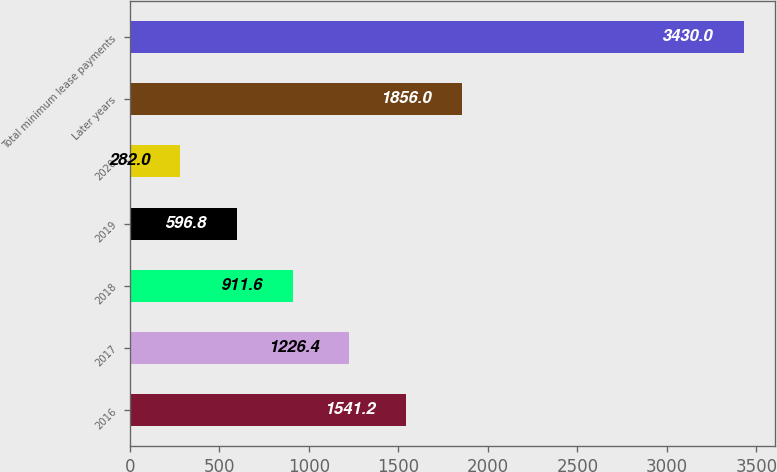Convert chart. <chart><loc_0><loc_0><loc_500><loc_500><bar_chart><fcel>2016<fcel>2017<fcel>2018<fcel>2019<fcel>2020<fcel>Later years<fcel>Total minimum lease payments<nl><fcel>1541.2<fcel>1226.4<fcel>911.6<fcel>596.8<fcel>282<fcel>1856<fcel>3430<nl></chart> 